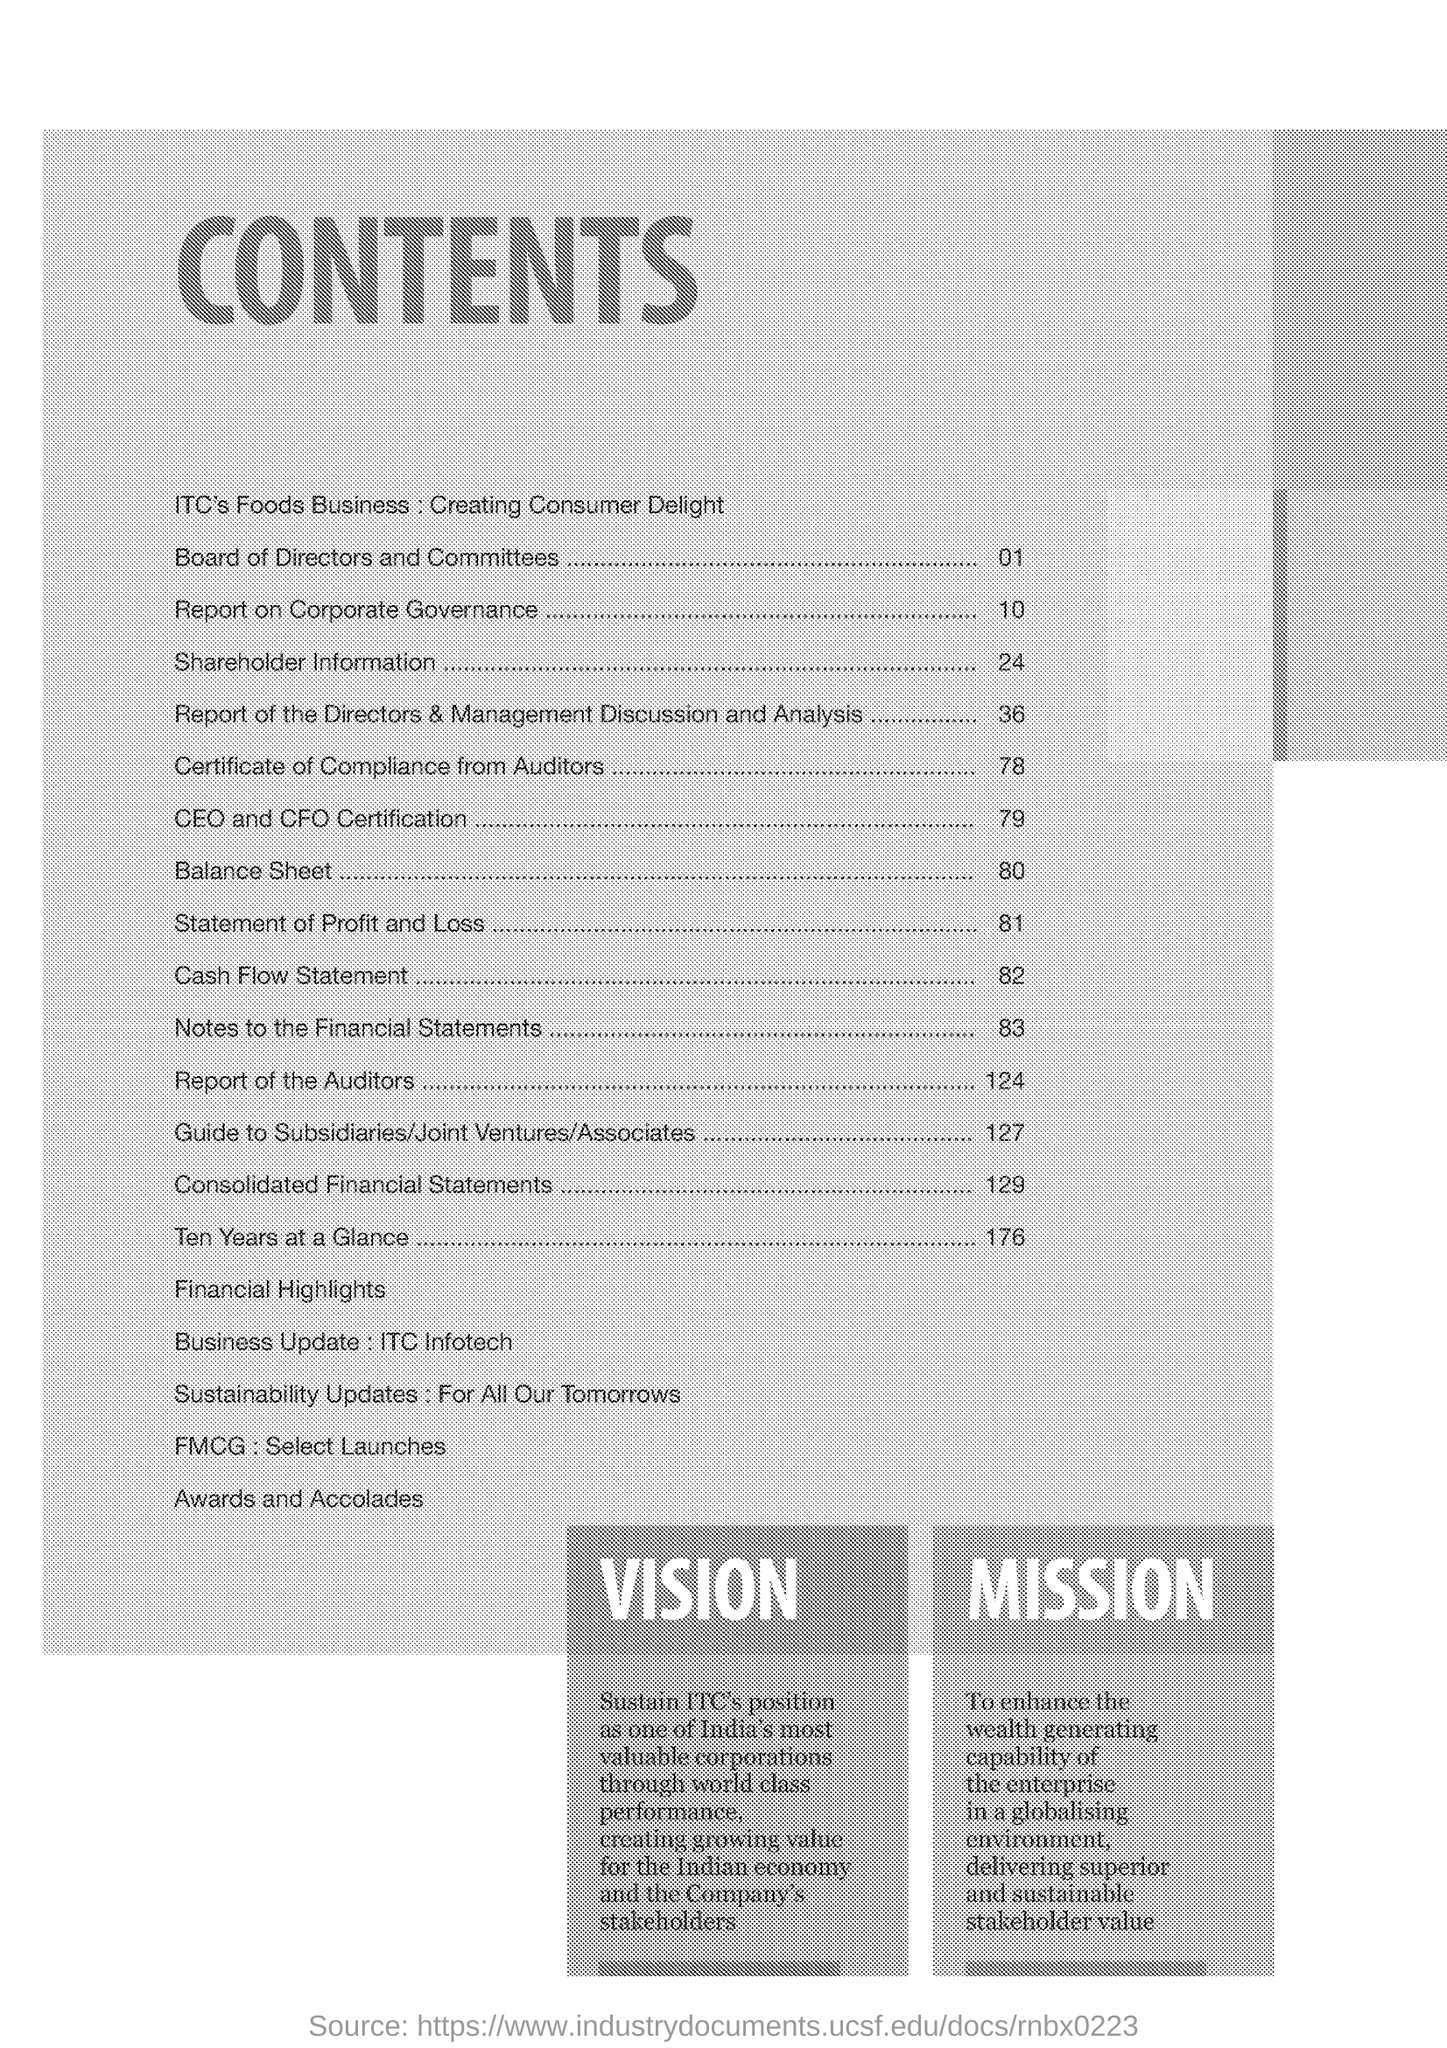What is the Title of the document ?
Offer a very short reply. CONTENTS. What is the page number for balance sheet ?
Provide a succinct answer. 80. What is the page number for Shareholder Information ?
Make the answer very short. 24. 